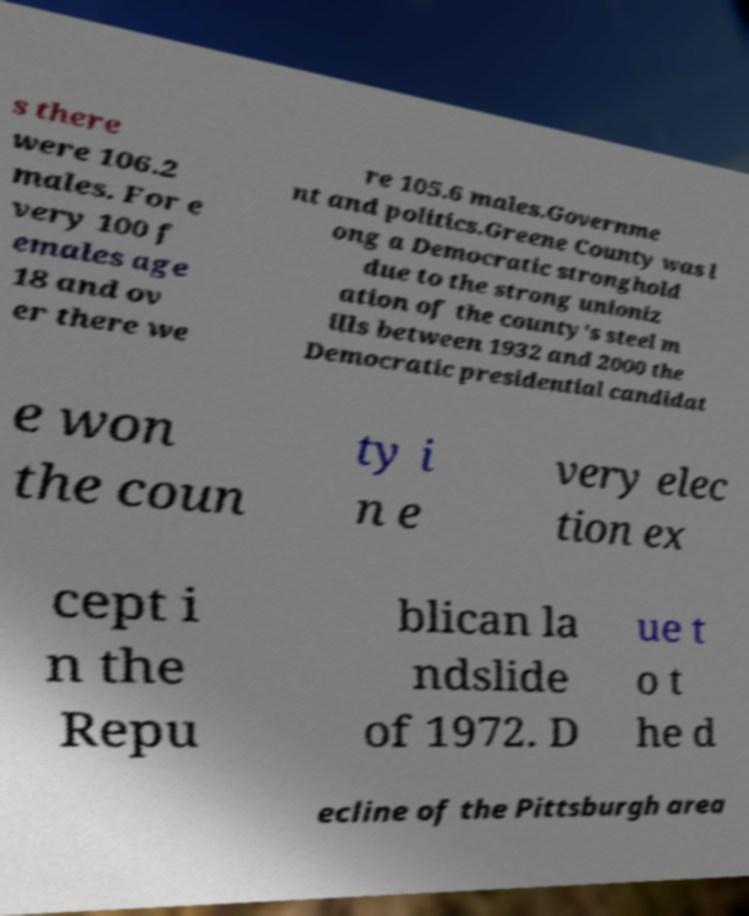Can you accurately transcribe the text from the provided image for me? s there were 106.2 males. For e very 100 f emales age 18 and ov er there we re 105.6 males.Governme nt and politics.Greene County was l ong a Democratic stronghold due to the strong unioniz ation of the county's steel m ills between 1932 and 2000 the Democratic presidential candidat e won the coun ty i n e very elec tion ex cept i n the Repu blican la ndslide of 1972. D ue t o t he d ecline of the Pittsburgh area 